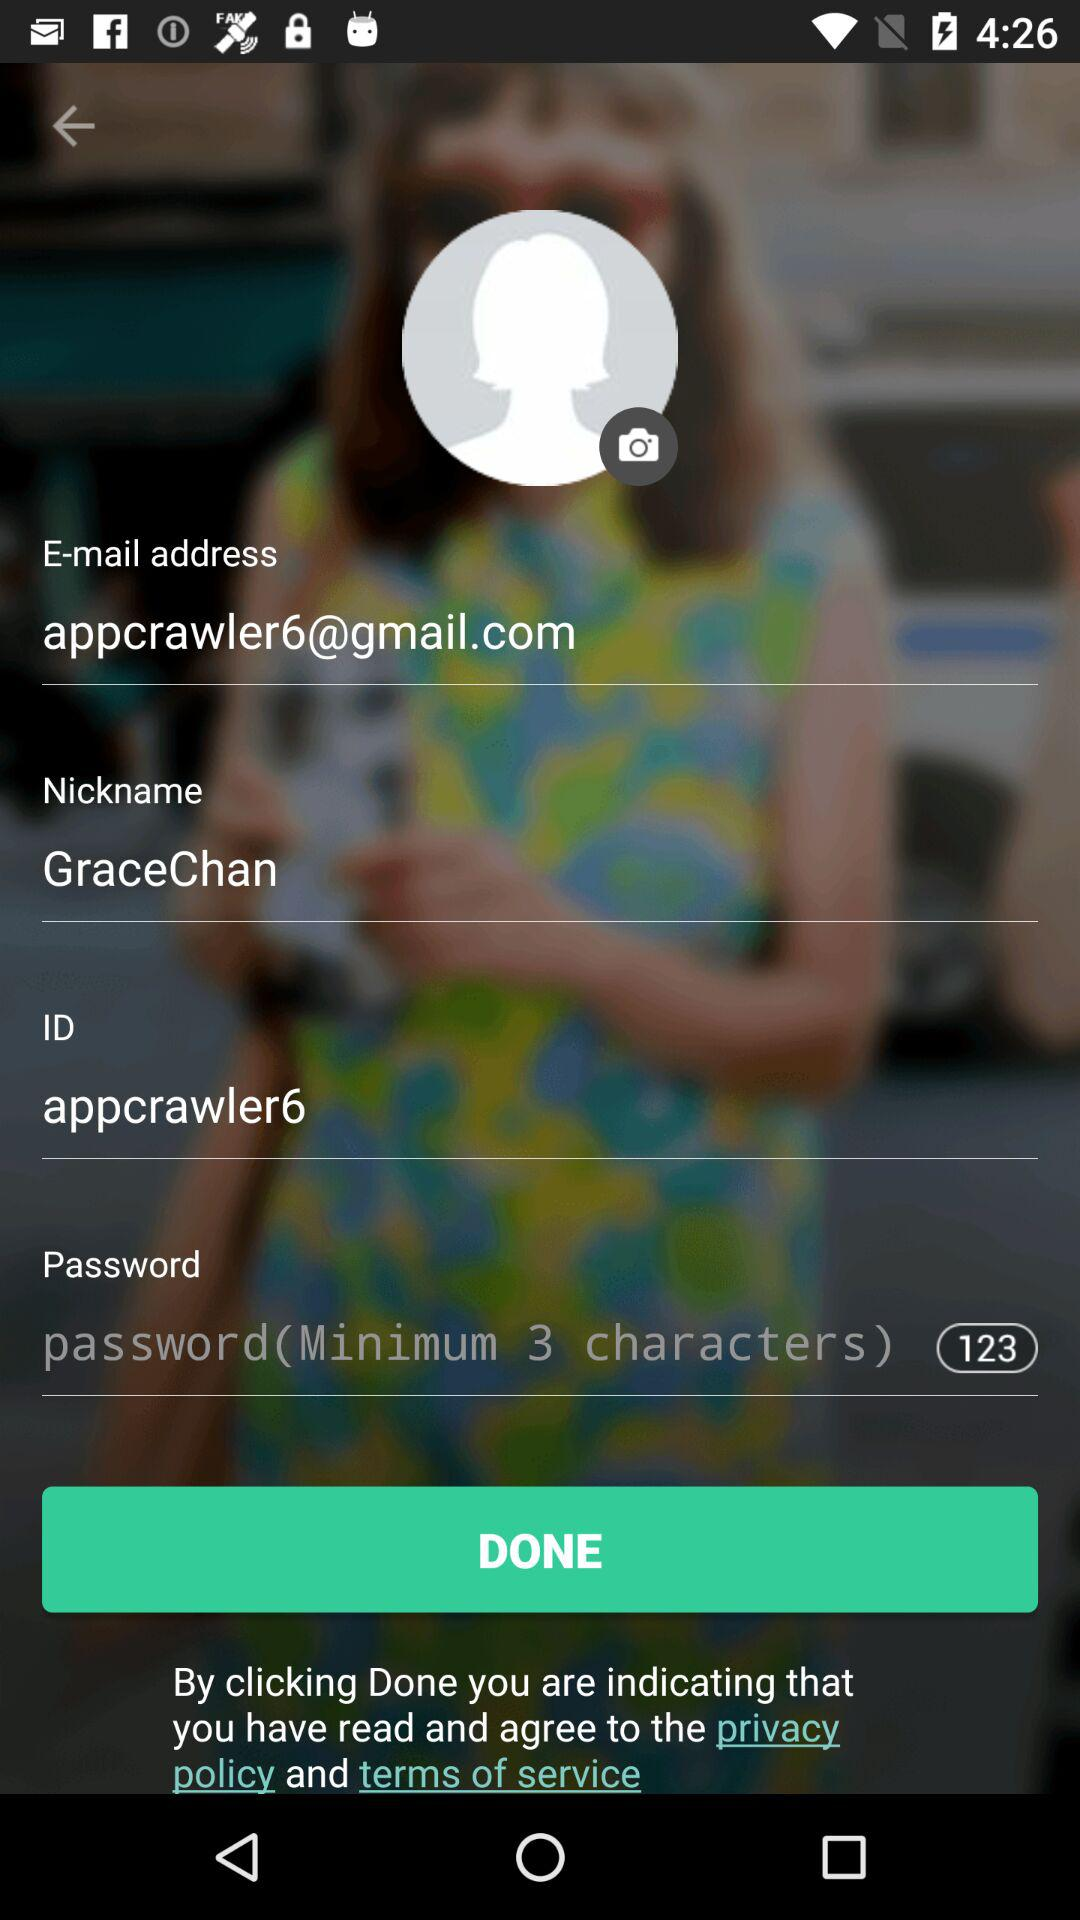What's the email address? The email address is appcrawler6@gmail.com. 